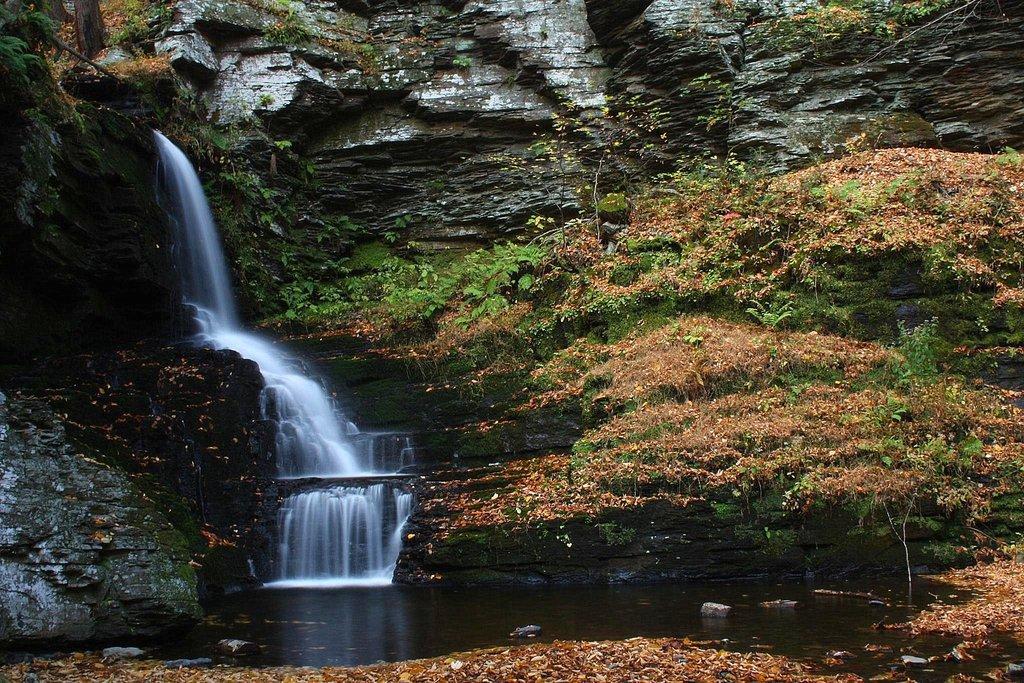How would you summarize this image in a sentence or two? In this image, we can see some rock hills and the waterfall. We can also see some plants and the ground with with some dried leaves. 